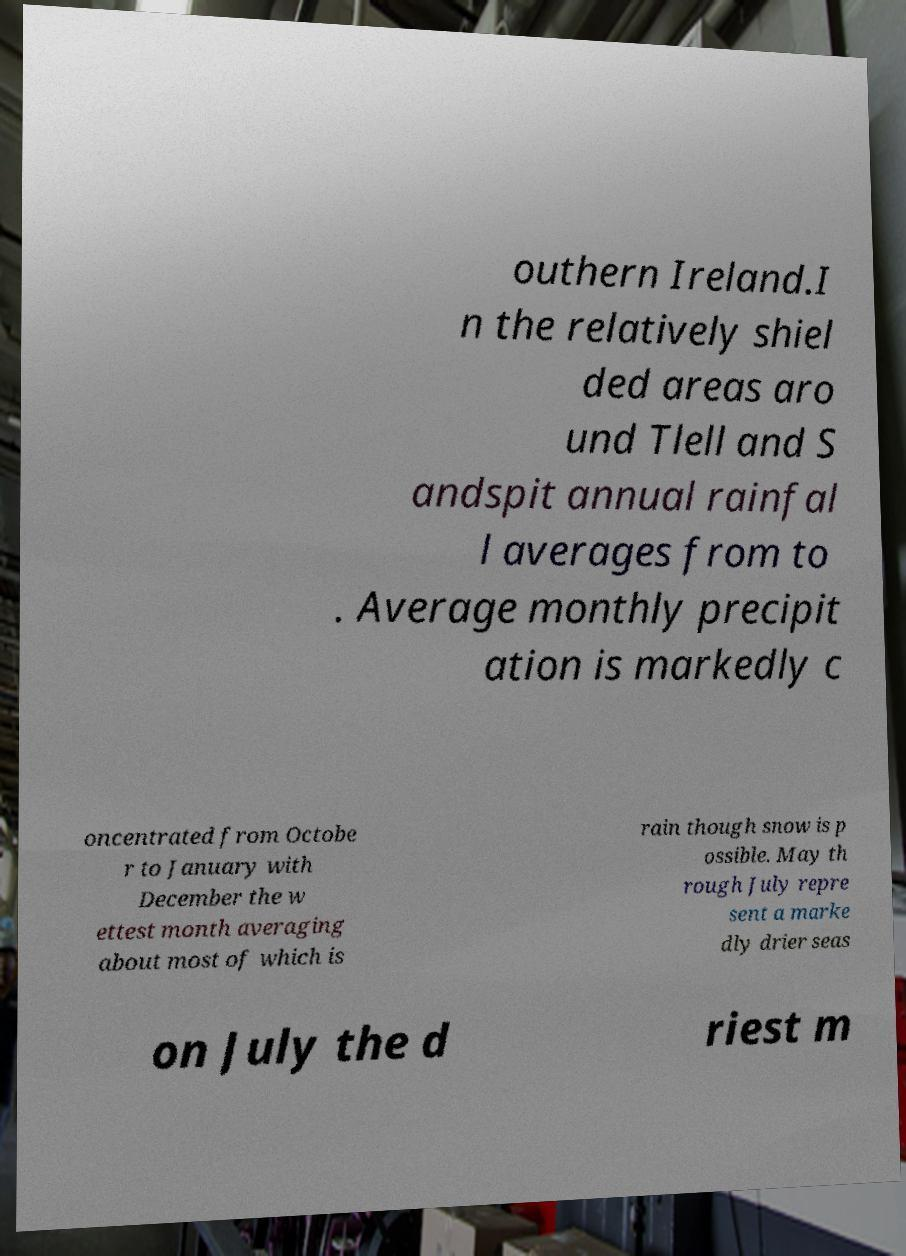Can you read and provide the text displayed in the image?This photo seems to have some interesting text. Can you extract and type it out for me? outhern Ireland.I n the relatively shiel ded areas aro und Tlell and S andspit annual rainfal l averages from to . Average monthly precipit ation is markedly c oncentrated from Octobe r to January with December the w ettest month averaging about most of which is rain though snow is p ossible. May th rough July repre sent a marke dly drier seas on July the d riest m 